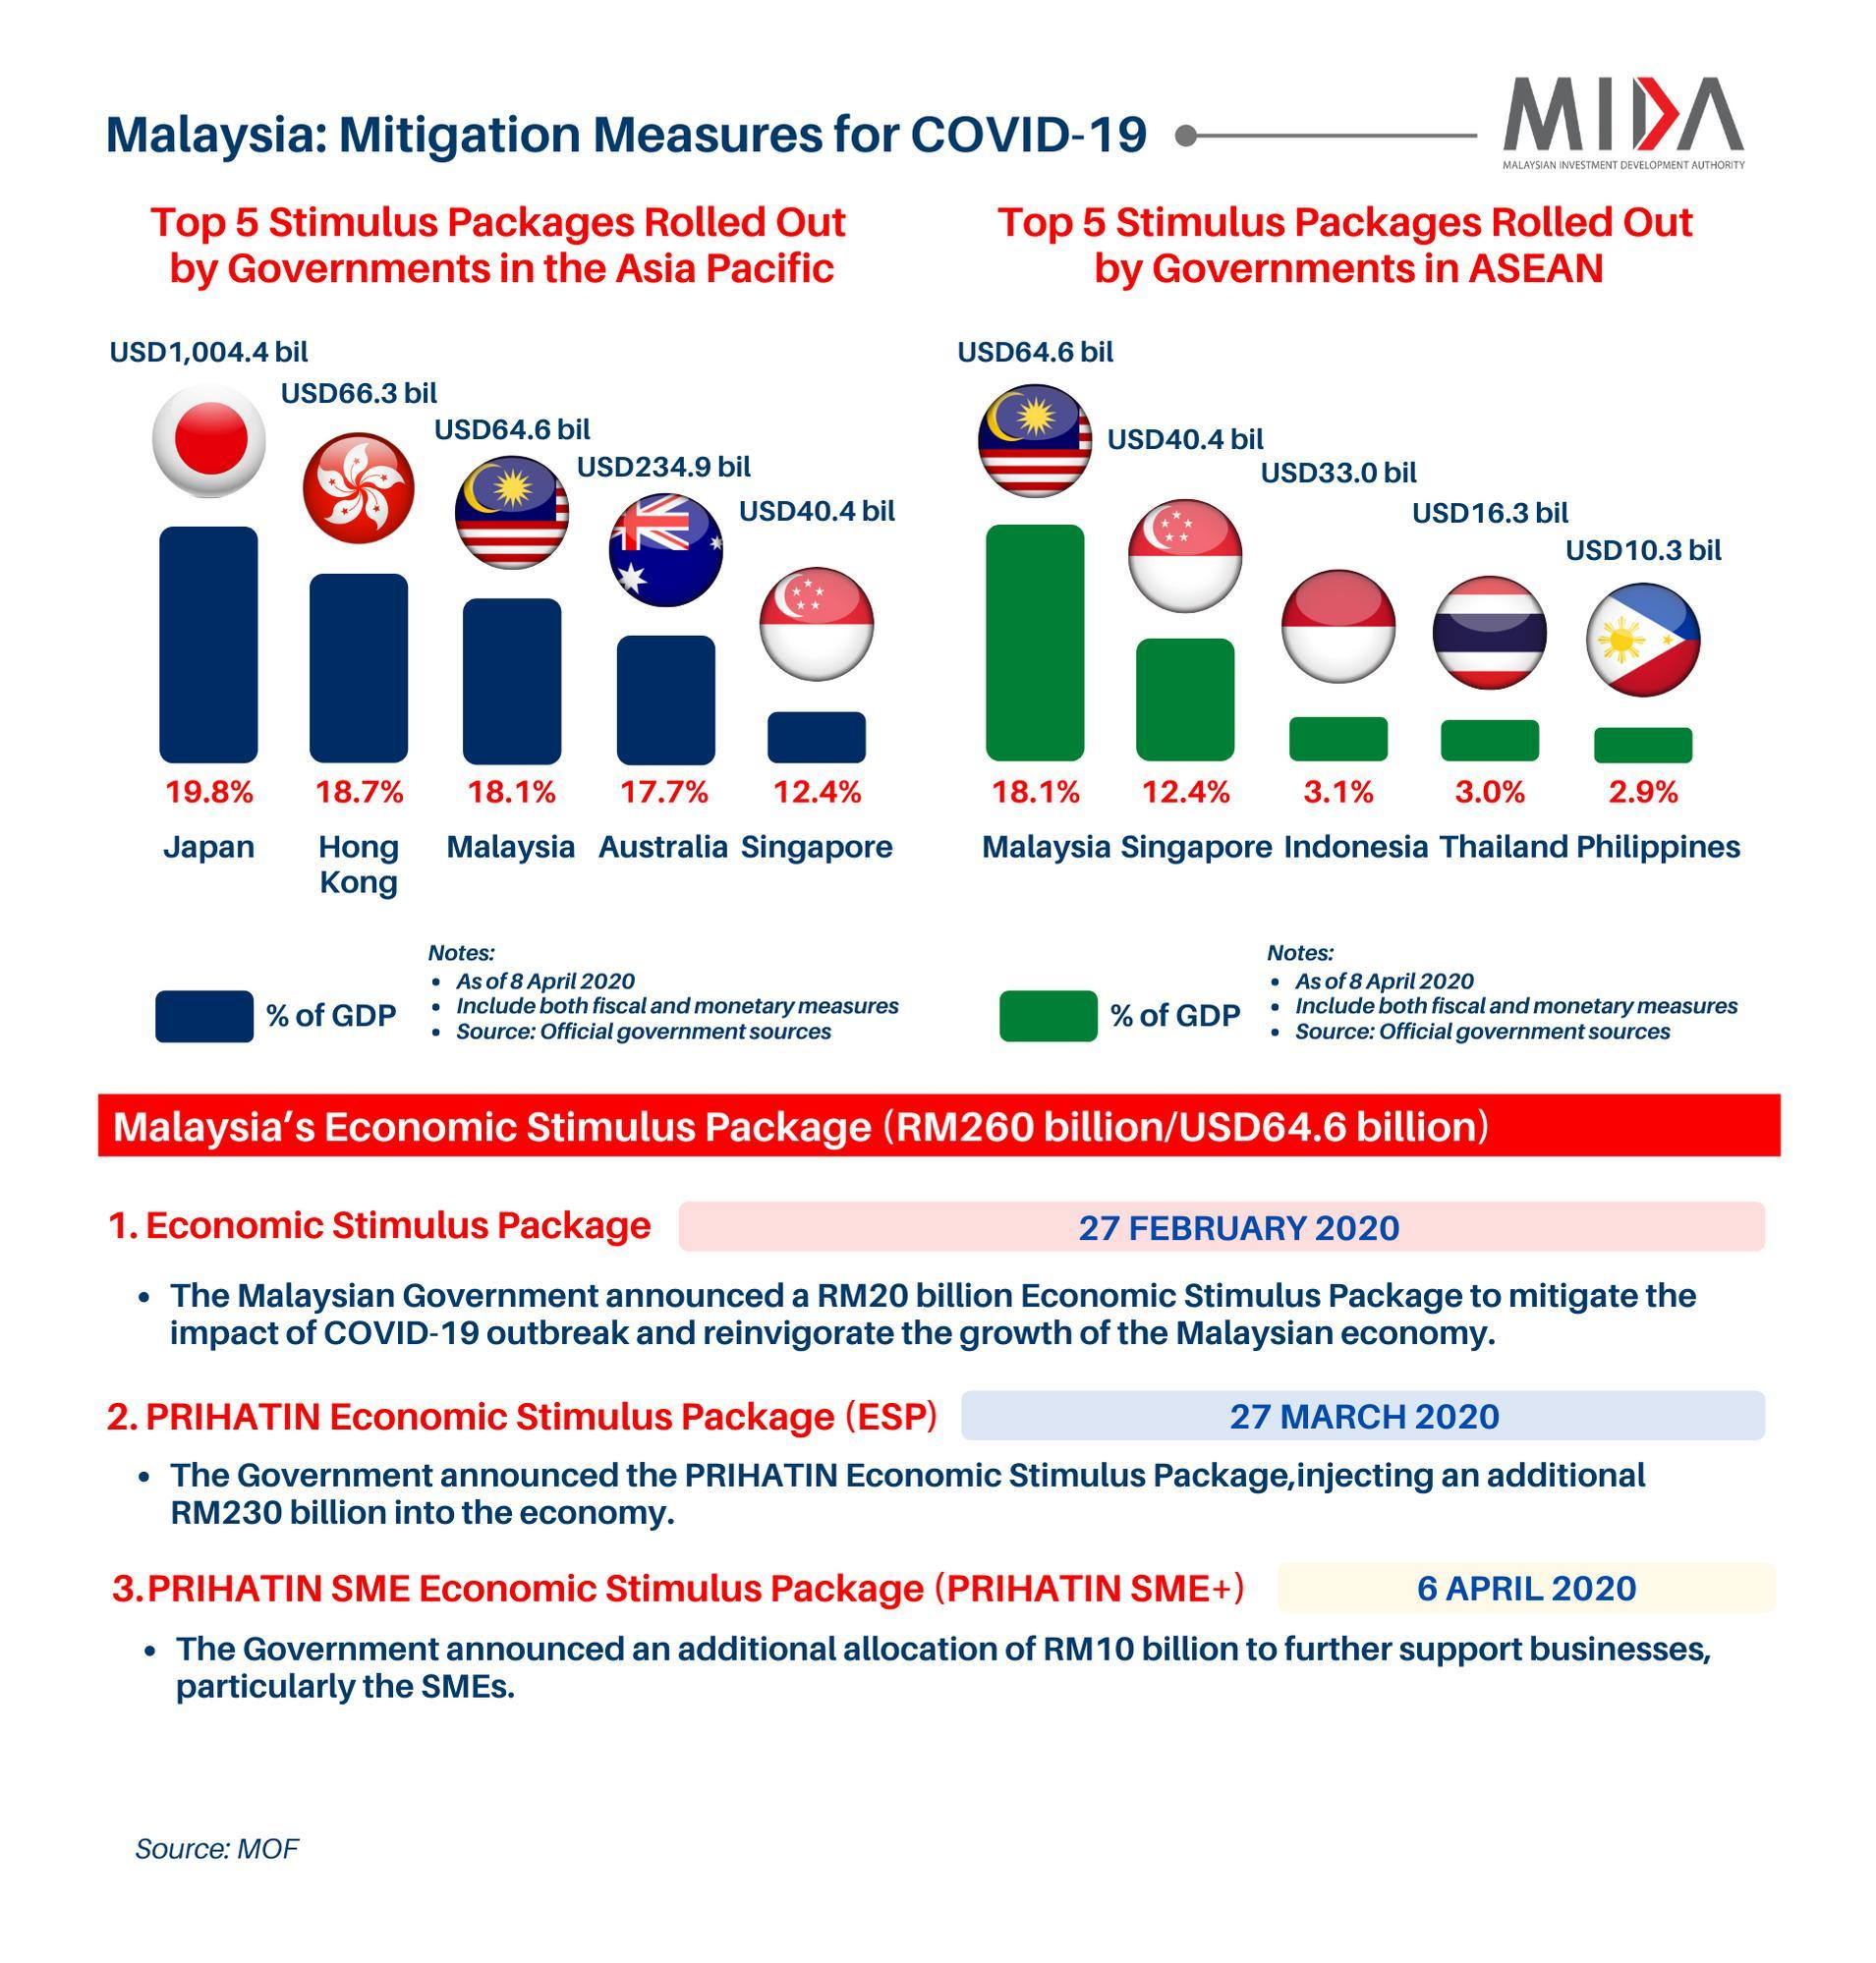Which Asian Government has the third highest stimulus package in terms of GDP?
Answer the question with a short phrase. Malaysia What is the number of Economic packages of Malaysia? 3 Which ASEAN Government has the second lowest stimulus package in terms of GDP? Thailand Which Asian Government has the second highest stimulus package in terms of GDP? Hong Kong How many ASEAN governments has stimulus package less than USD40 bil in terms of GDP? 3 Which ASEAN Government has the third highest stimulus package? Indonesia Which Asian Government has the second lowest stimulus package in terms of GDP? Australia Which ASEAN Government has the second highest stimulus package in terms of GDP? Singapore 